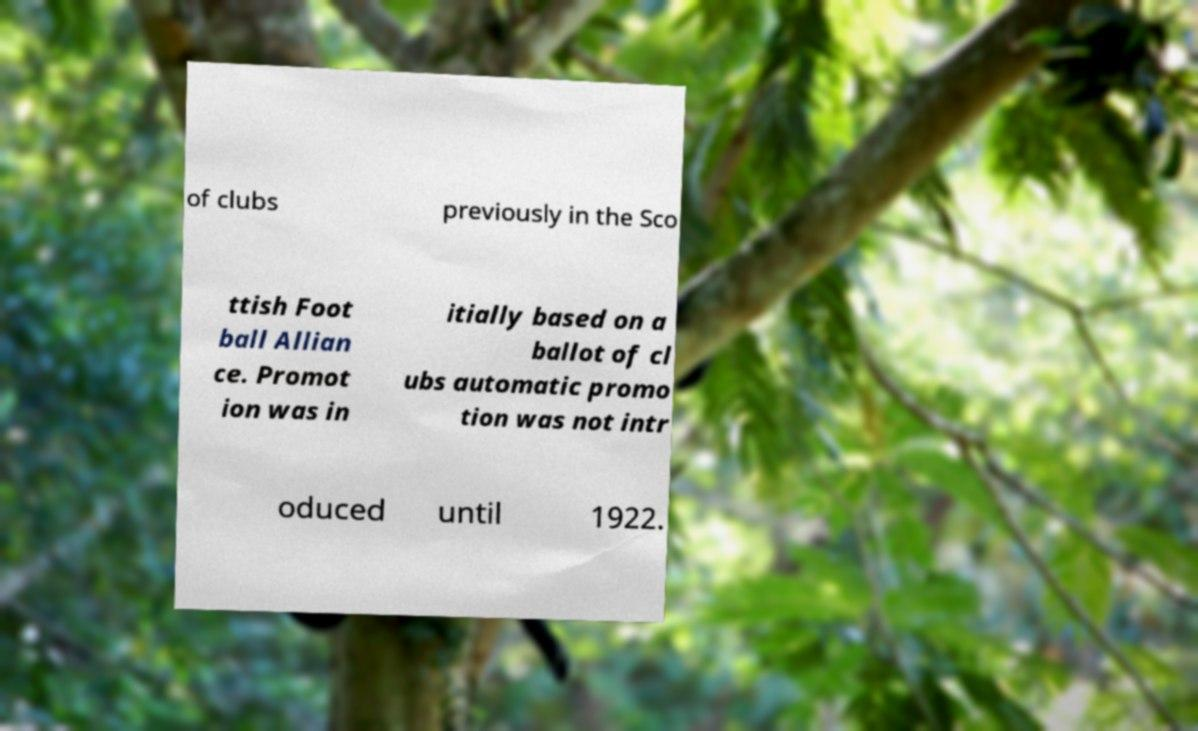Could you assist in decoding the text presented in this image and type it out clearly? of clubs previously in the Sco ttish Foot ball Allian ce. Promot ion was in itially based on a ballot of cl ubs automatic promo tion was not intr oduced until 1922. 